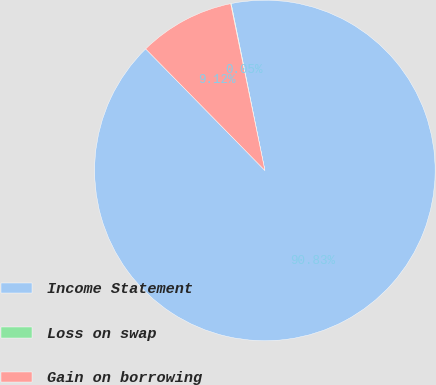<chart> <loc_0><loc_0><loc_500><loc_500><pie_chart><fcel>Income Statement<fcel>Loss on swap<fcel>Gain on borrowing<nl><fcel>90.83%<fcel>0.05%<fcel>9.12%<nl></chart> 